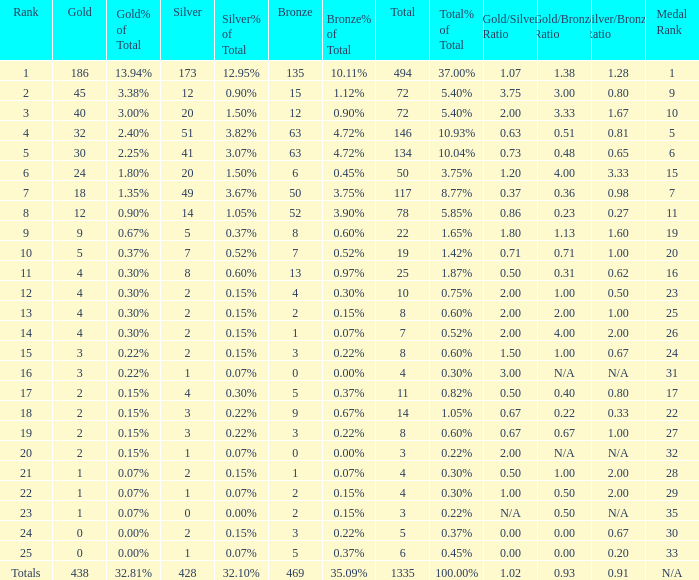What is the total amount of gold medals when there were more than 20 silvers and there were 135 bronze medals? 1.0. 